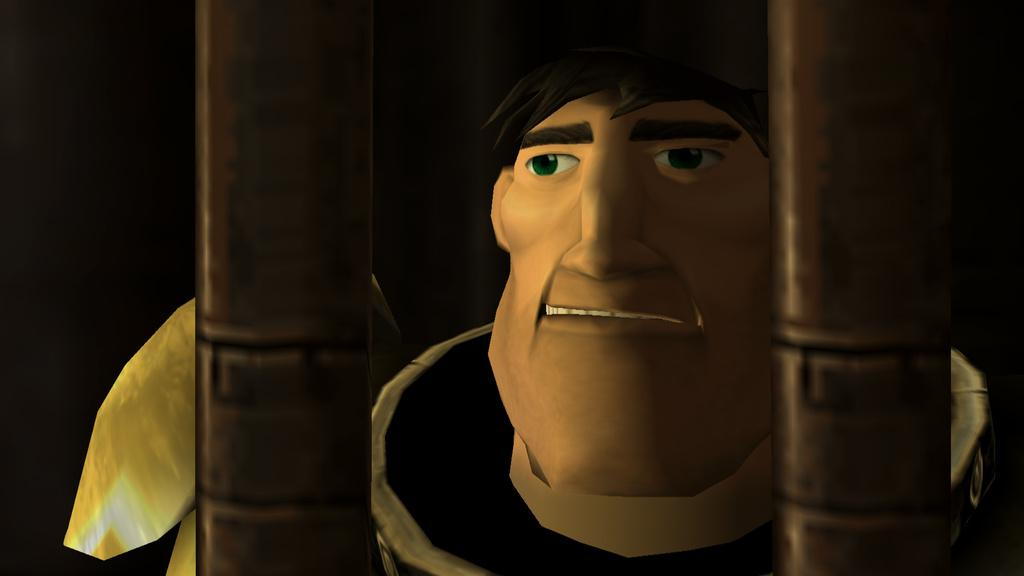What is the man in the image wearing? The man in the image is wearing Armour. What is the man doing in the image? The man is standing over a place. What can be seen in front of the man? There are moles present in front of the man. What type of attraction can be seen in the background of the image? There is no attraction visible in the background of the image. 